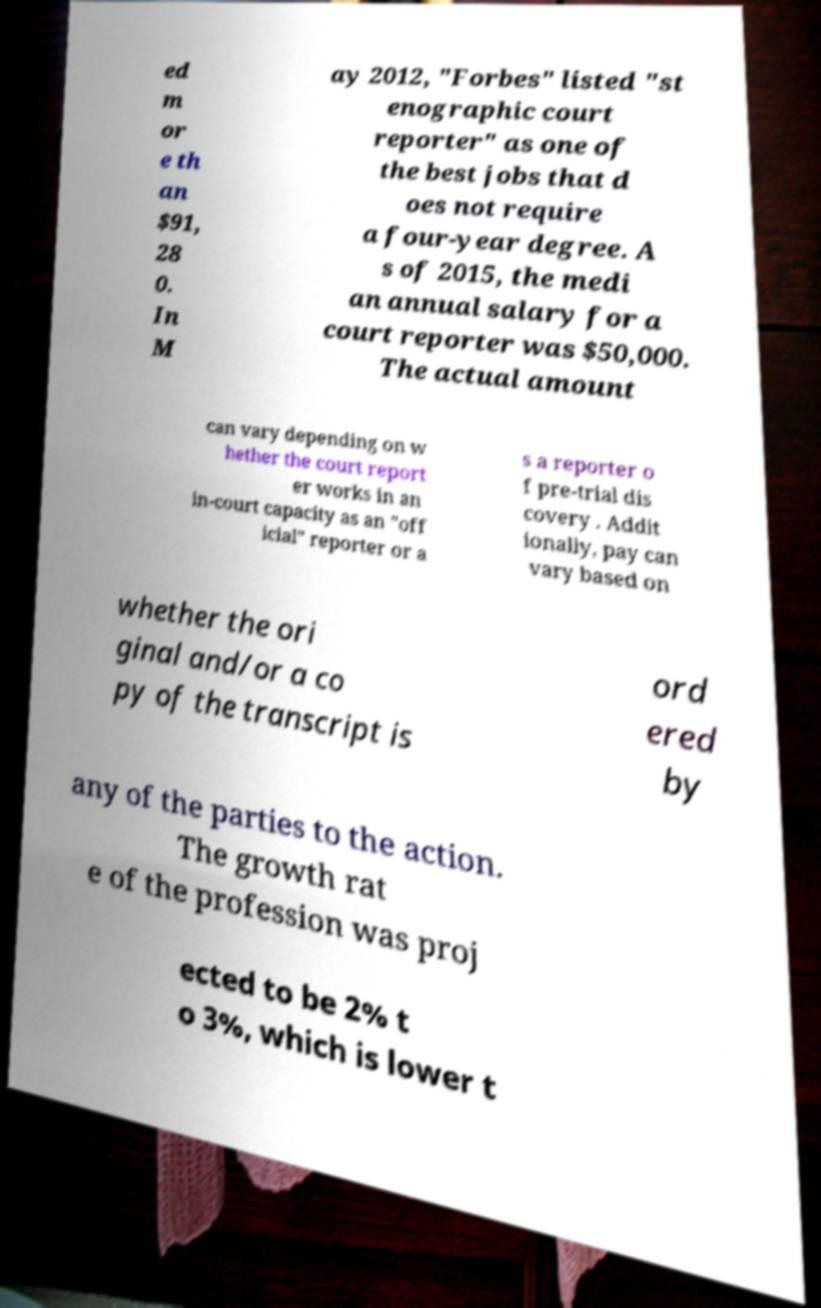Can you accurately transcribe the text from the provided image for me? ed m or e th an $91, 28 0. In M ay 2012, "Forbes" listed "st enographic court reporter" as one of the best jobs that d oes not require a four-year degree. A s of 2015, the medi an annual salary for a court reporter was $50,000. The actual amount can vary depending on w hether the court report er works in an in-court capacity as an "off icial" reporter or a s a reporter o f pre-trial dis covery . Addit ionally, pay can vary based on whether the ori ginal and/or a co py of the transcript is ord ered by any of the parties to the action. The growth rat e of the profession was proj ected to be 2% t o 3%, which is lower t 